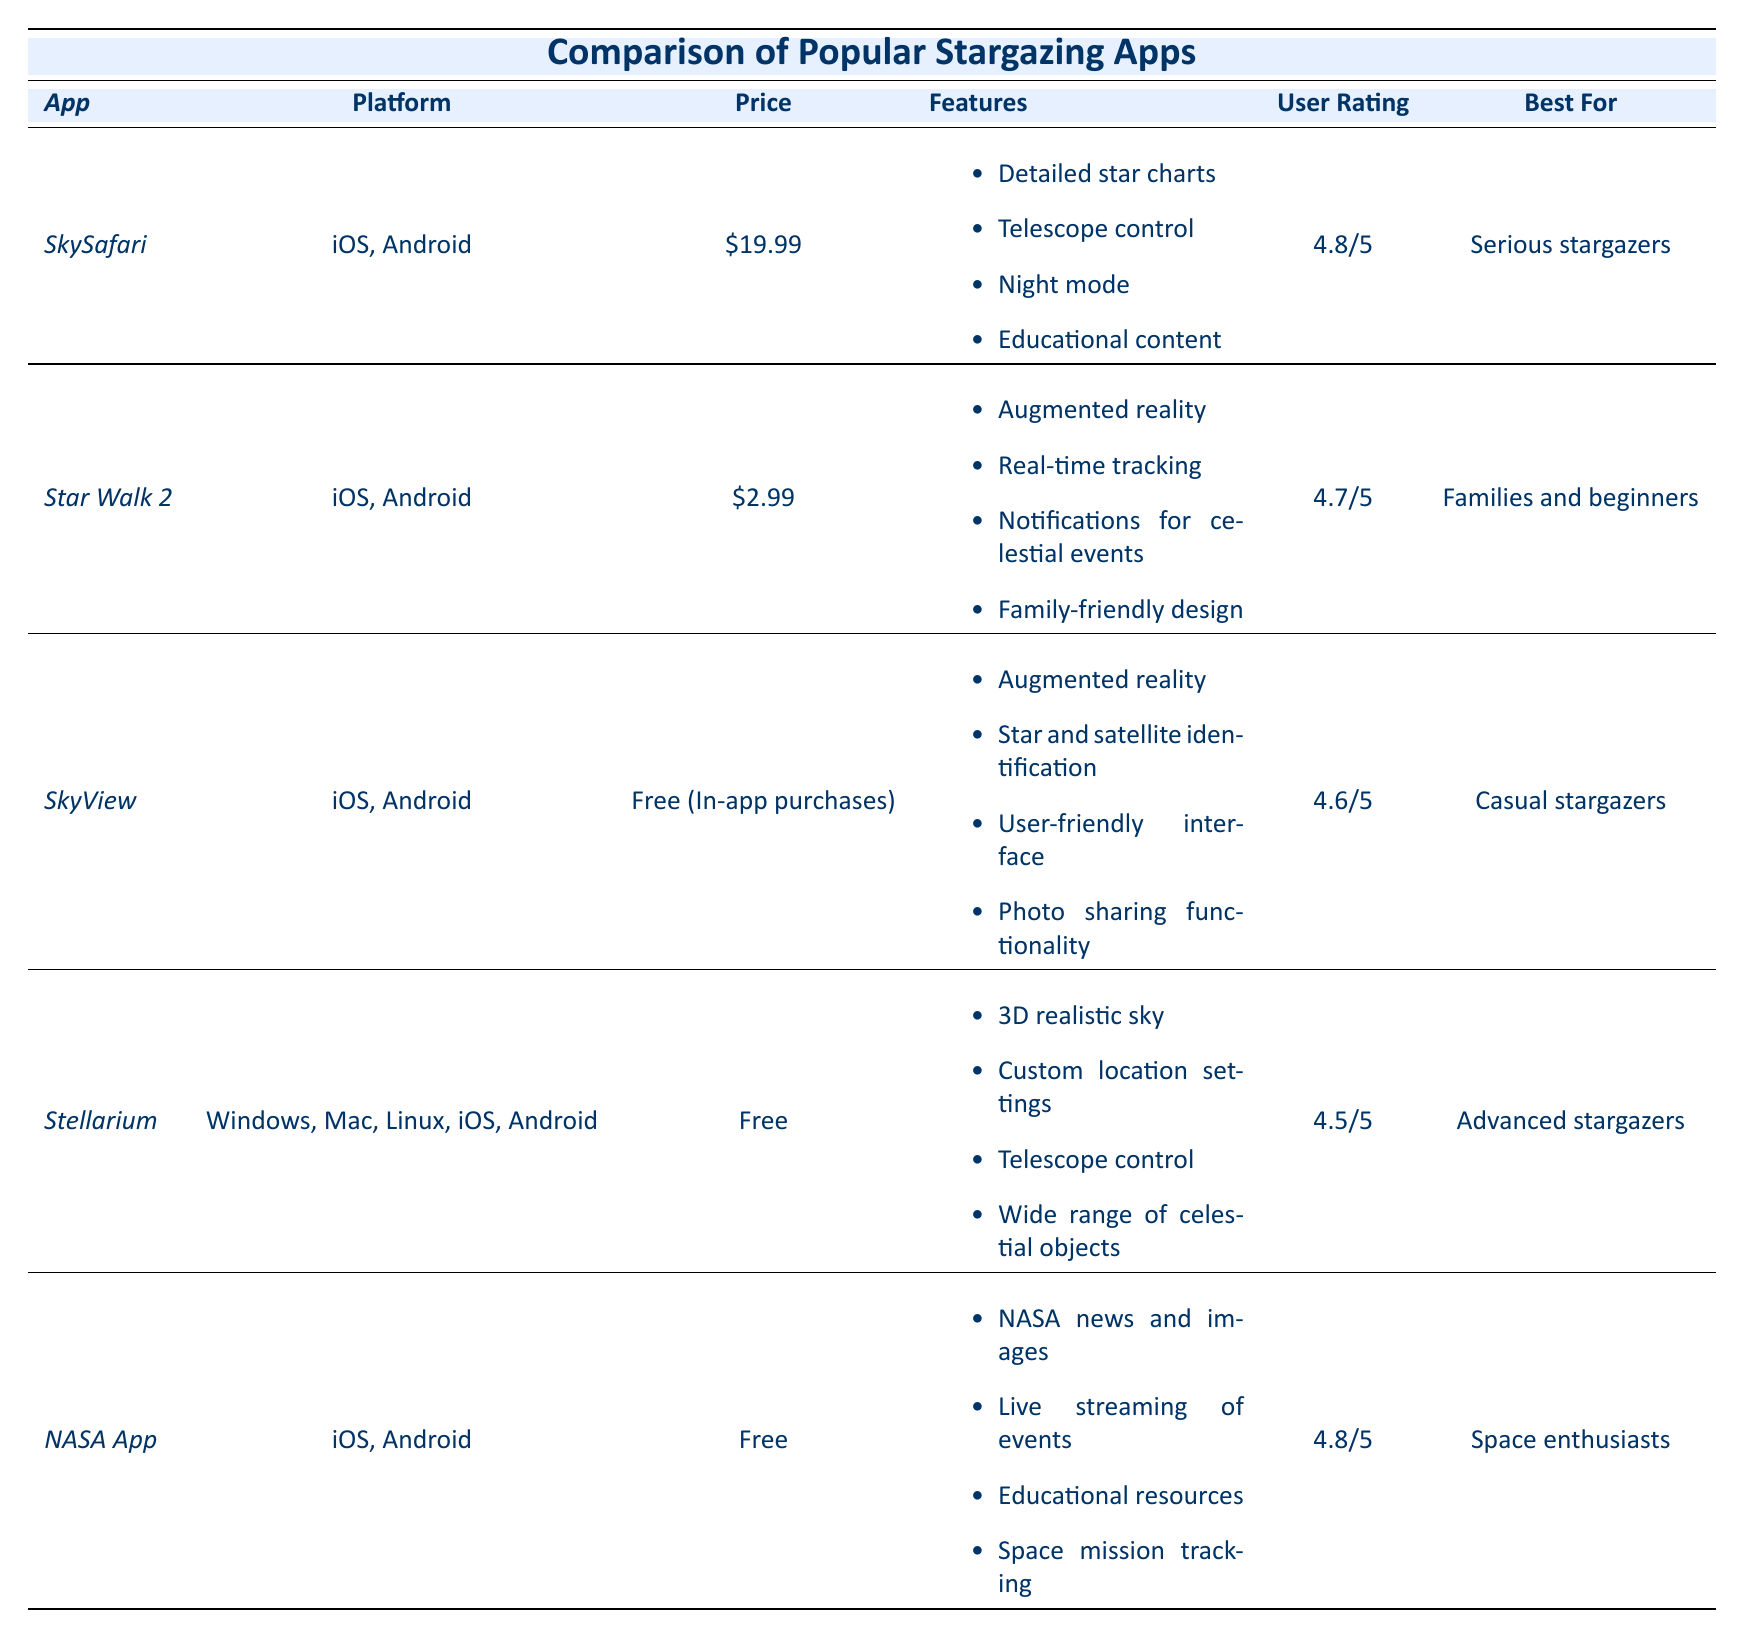What is the price of SkySafari? The price is listed in the table under the "Price" column for the SkySafari app. It shows "$19.99".
Answer: $19.99 Which app is rated the highest? The highest user rating in the table is 4.8/5. Both the SkySafari and NASA App have this rating, but NASA App is free.
Answer: Both SkySafari and NASA App are rated 4.8/5 Does SkyView have a price? SkyView is listed as "Free (In-app purchases)" which indicates that it can be downloaded for free, but additional features may require payment.
Answer: Yes, it is free but has in-app purchases What features does Star Walk 2 offer? The features of Star Walk 2 are listed in the table, including augmented reality, real-time tracking, notifications for celestial events, and family-friendly design.
Answer: Augmented reality, real-time tracking, notifications for celestial events, family-friendly design Which app is best for serious stargazers? The table indicates that the app best suited for serious stargazers is SkySafari, as it is specified under the "Best For" column.
Answer: SkySafari What is the average user rating of the apps listed? To find the average user rating, you add up the user ratings: 4.8 + 4.7 + 4.6 + 4.5 + 4.8 = 24.4, then divide by 5 (number of apps). So, 24.4 / 5 = 4.88.
Answer: 4.88 What platform is Stellarium available on? The platforms for Stellarium are listed in the "Platform" column, which shows it is available on Windows, Mac, Linux, iOS, and Android.
Answer: Windows, Mac, Linux, iOS, Android Is there any app that is free of charge? The "Price" column indicates that both Stellarium and NASA App are free, confirming that there are apps available at no charge.
Answer: Yes, Stellarium and NASA App are free Which app has telescope control feature? According to the "Features" column, both SkySafari and Stellarium mention telescope control in the features listed for each app.
Answer: SkySafari and Stellarium How many total features does the NASA App have? The NASA App has four features listed in the table: NASA news and images, live streaming of events, educational resources, and space mission tracking. Count these features to find the total.
Answer: 4 features What distinguishes Star Walk 2 from SkyView in terms of user rating? By comparing the user ratings in the "User Rating" column, Star Walk 2 has 4.7/5 while SkyView has 4.6/5. Star Walk 2 is rated higher by 0.1.
Answer: Star Walk 2 is rated higher by 0.1 